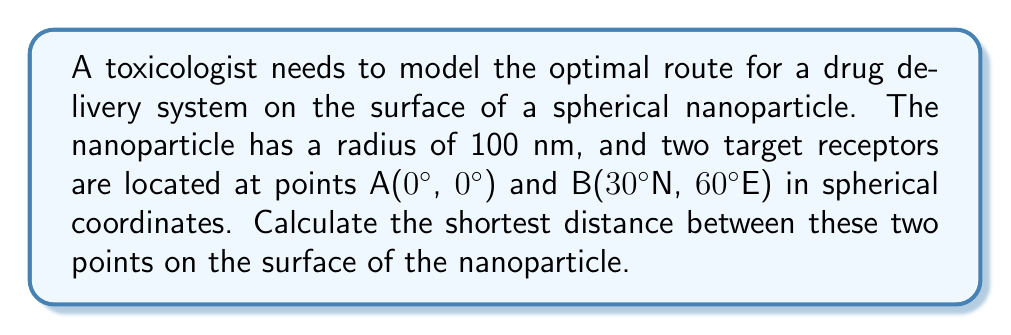Teach me how to tackle this problem. To find the shortest path between two points on a spherical surface, we need to calculate the great circle distance. This can be done using the Haversine formula:

1) First, convert the latitude and longitude to radians:
   $\phi_1 = 0° \times \frac{\pi}{180} = 0$
   $\lambda_1 = 0° \times \frac{\pi}{180} = 0$
   $\phi_2 = 30° \times \frac{\pi}{180} = \frac{\pi}{6}$
   $\lambda_2 = 60° \times \frac{\pi}{180} = \frac{\pi}{3}$

2) Calculate the central angle $\Delta\sigma$ using the Haversine formula:
   $$\Delta\sigma = 2 \arcsin\left(\sqrt{\sin^2\left(\frac{\phi_2 - \phi_1}{2}\right) + \cos\phi_1 \cos\phi_2 \sin^2\left(\frac{\lambda_2 - \lambda_1}{2}\right)}\right)$$

3) Substitute the values:
   $$\Delta\sigma = 2 \arcsin\left(\sqrt{\sin^2\left(\frac{\pi/6 - 0}{2}\right) + \cos(0) \cos(\pi/6) \sin^2\left(\frac{\pi/3 - 0}{2}\right)}\right)$$

4) Simplify:
   $$\Delta\sigma = 2 \arcsin\left(\sqrt{\sin^2\left(\frac{\pi}{12}\right) + \frac{\sqrt{3}}{2} \sin^2\left(\frac{\pi}{6}\right)}\right)$$

5) Calculate the result:
   $\Delta\sigma \approx 1.0472$ radians

6) The shortest distance $d$ on the surface is the arc length, which is the product of the central angle and the radius:
   $d = r \Delta\sigma = 100 \text{ nm} \times 1.0472 \approx 104.72 \text{ nm}$
Answer: 104.72 nm 